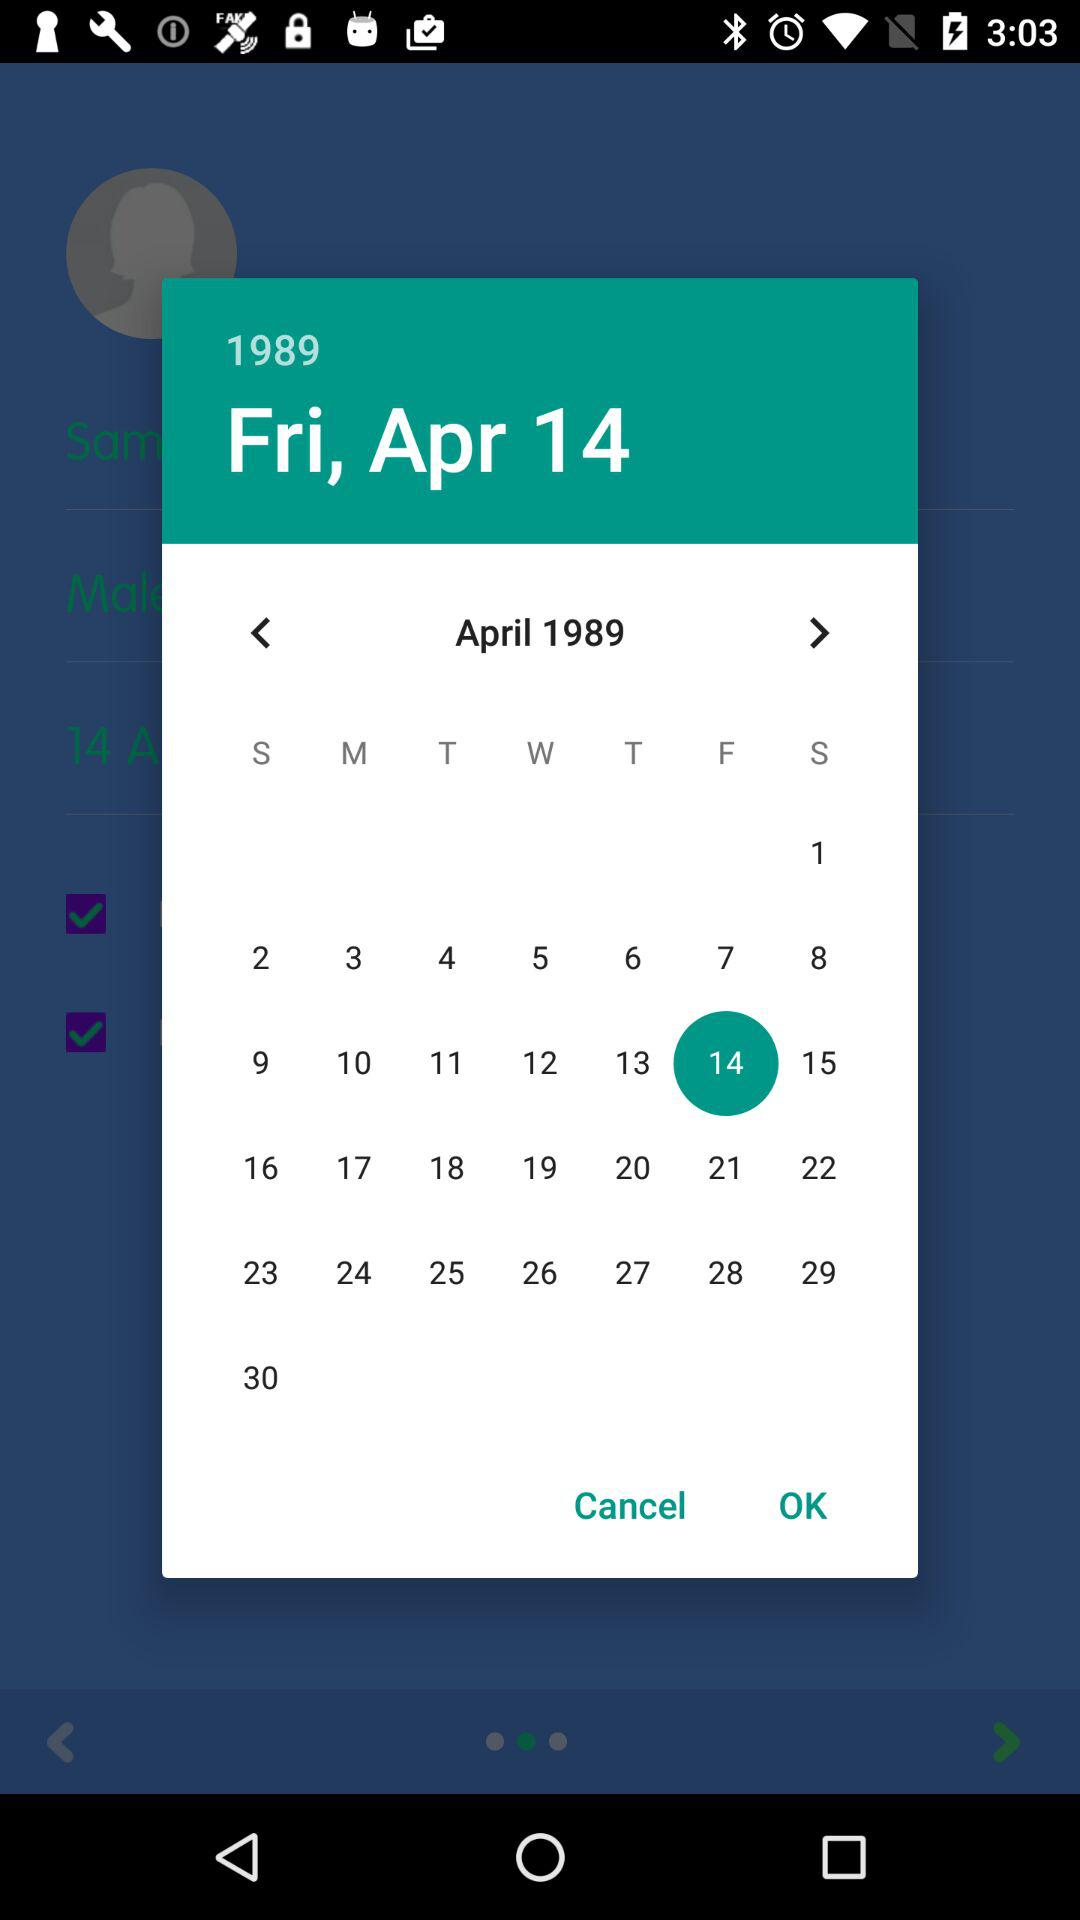Which holiday falls on Friday, April 14, 1989?
When the provided information is insufficient, respond with <no answer>. <no answer> 